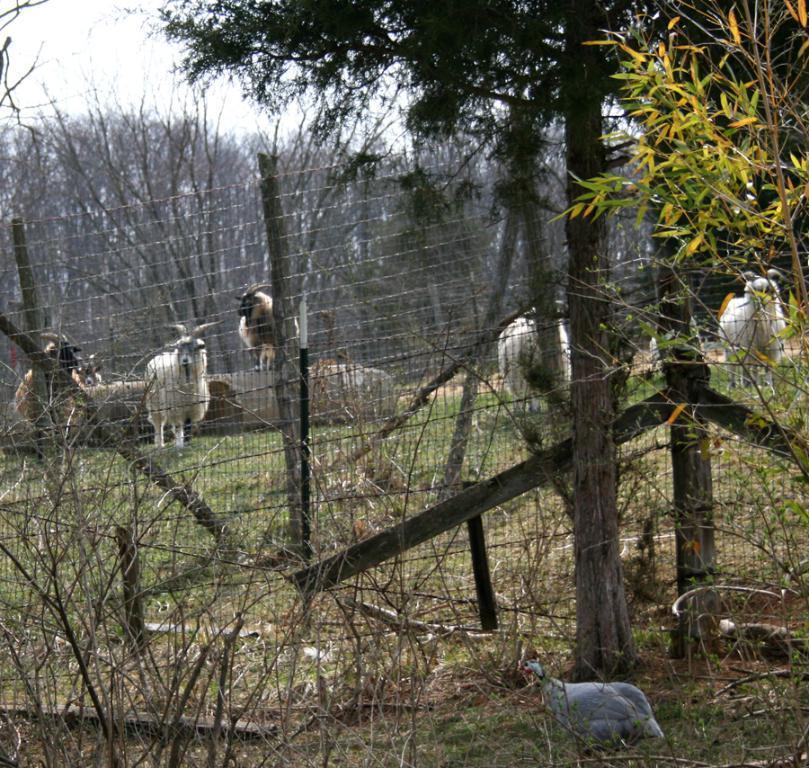Please provide a concise description of this image. This image consists of herds of animals and birds in a ground, fence, grass, trees and the sky. This image is taken may be during a day. 